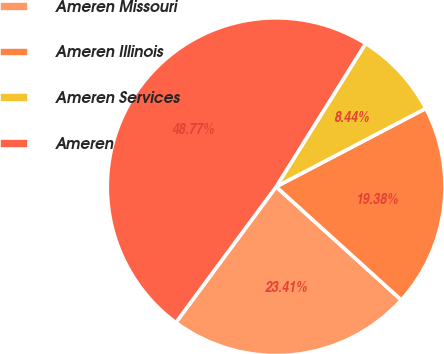Convert chart. <chart><loc_0><loc_0><loc_500><loc_500><pie_chart><fcel>Ameren Missouri<fcel>Ameren Illinois<fcel>Ameren Services<fcel>Ameren<nl><fcel>23.41%<fcel>19.38%<fcel>8.44%<fcel>48.77%<nl></chart> 